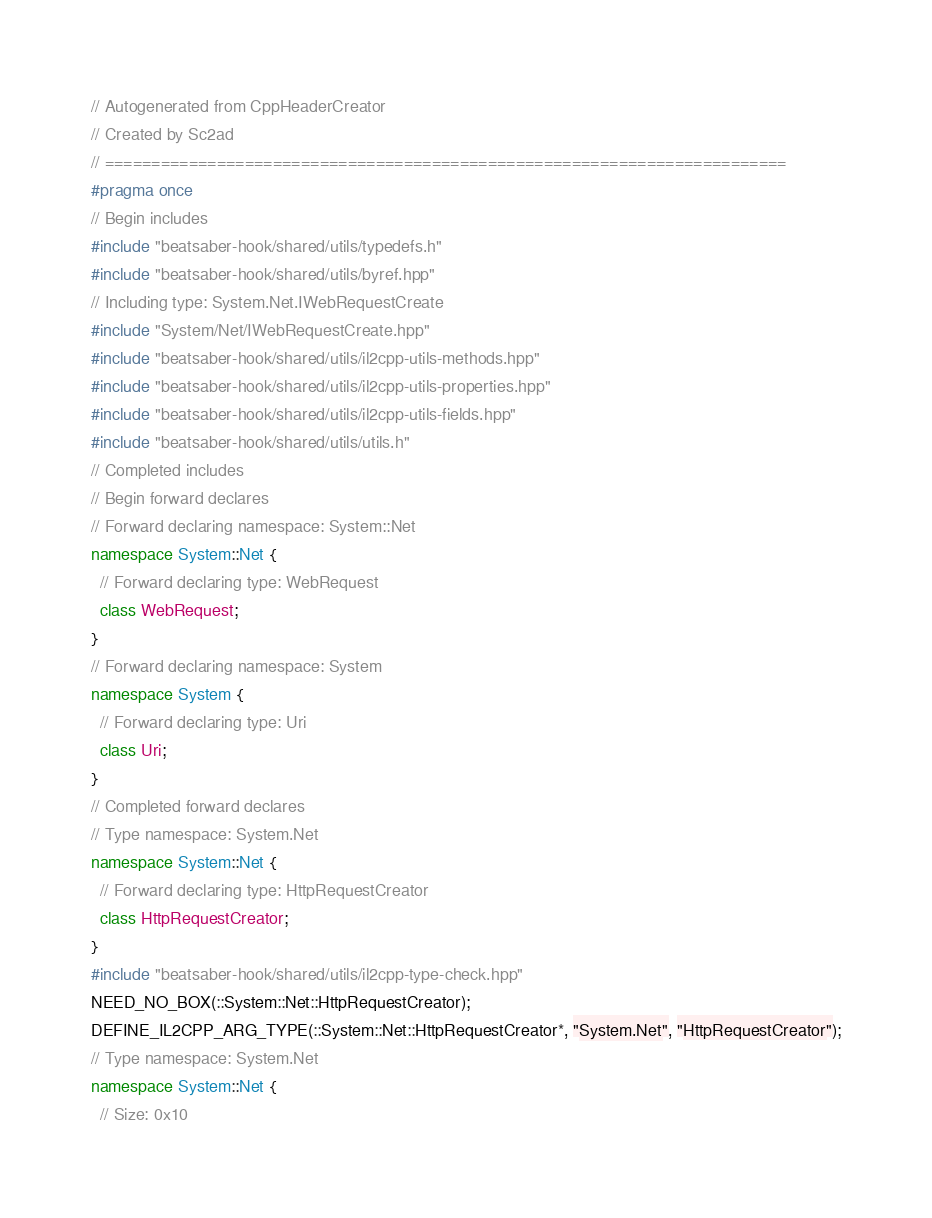Convert code to text. <code><loc_0><loc_0><loc_500><loc_500><_C++_>// Autogenerated from CppHeaderCreator
// Created by Sc2ad
// =========================================================================
#pragma once
// Begin includes
#include "beatsaber-hook/shared/utils/typedefs.h"
#include "beatsaber-hook/shared/utils/byref.hpp"
// Including type: System.Net.IWebRequestCreate
#include "System/Net/IWebRequestCreate.hpp"
#include "beatsaber-hook/shared/utils/il2cpp-utils-methods.hpp"
#include "beatsaber-hook/shared/utils/il2cpp-utils-properties.hpp"
#include "beatsaber-hook/shared/utils/il2cpp-utils-fields.hpp"
#include "beatsaber-hook/shared/utils/utils.h"
// Completed includes
// Begin forward declares
// Forward declaring namespace: System::Net
namespace System::Net {
  // Forward declaring type: WebRequest
  class WebRequest;
}
// Forward declaring namespace: System
namespace System {
  // Forward declaring type: Uri
  class Uri;
}
// Completed forward declares
// Type namespace: System.Net
namespace System::Net {
  // Forward declaring type: HttpRequestCreator
  class HttpRequestCreator;
}
#include "beatsaber-hook/shared/utils/il2cpp-type-check.hpp"
NEED_NO_BOX(::System::Net::HttpRequestCreator);
DEFINE_IL2CPP_ARG_TYPE(::System::Net::HttpRequestCreator*, "System.Net", "HttpRequestCreator");
// Type namespace: System.Net
namespace System::Net {
  // Size: 0x10</code> 